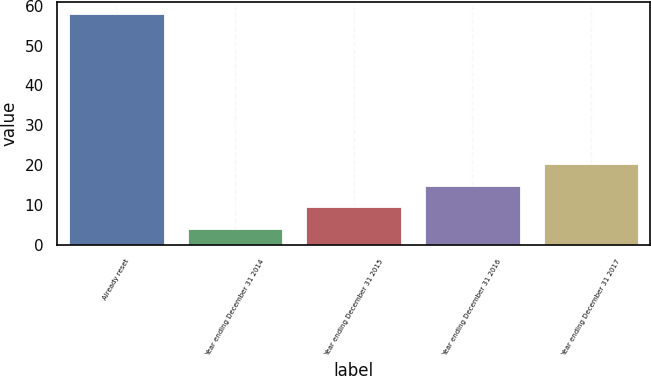Convert chart to OTSL. <chart><loc_0><loc_0><loc_500><loc_500><bar_chart><fcel>Already reset<fcel>Year ending December 31 2014<fcel>Year ending December 31 2015<fcel>Year ending December 31 2016<fcel>Year ending December 31 2017<nl><fcel>58<fcel>4<fcel>9.4<fcel>14.8<fcel>20.2<nl></chart> 